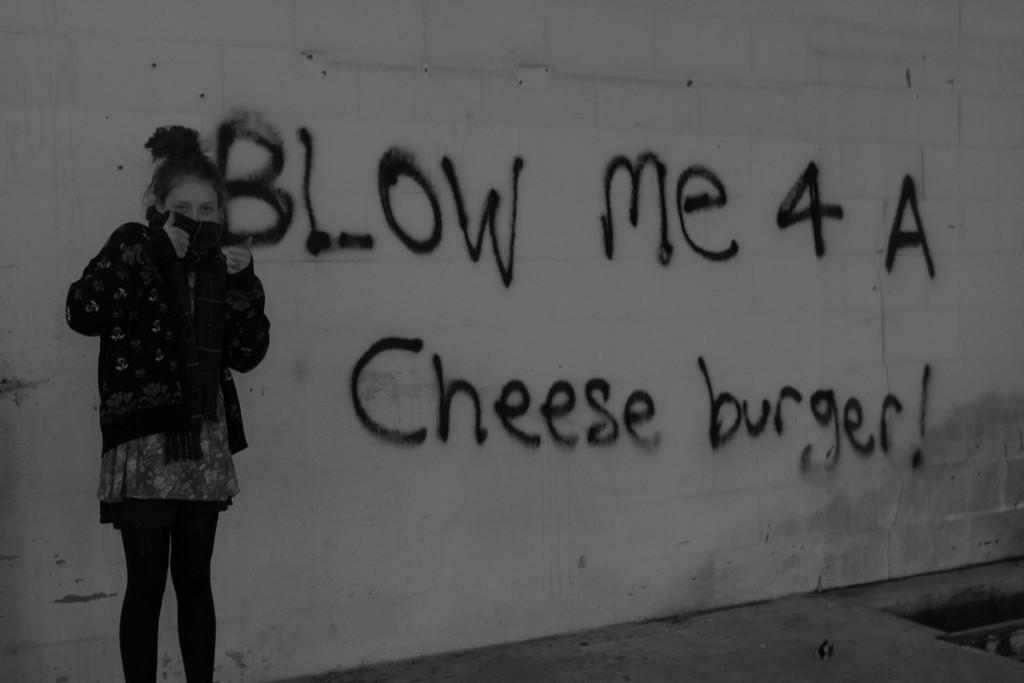Could you give a brief overview of what you see in this image? In this image we can see a woman standing on the floor and in the background there is a wall with some text. 